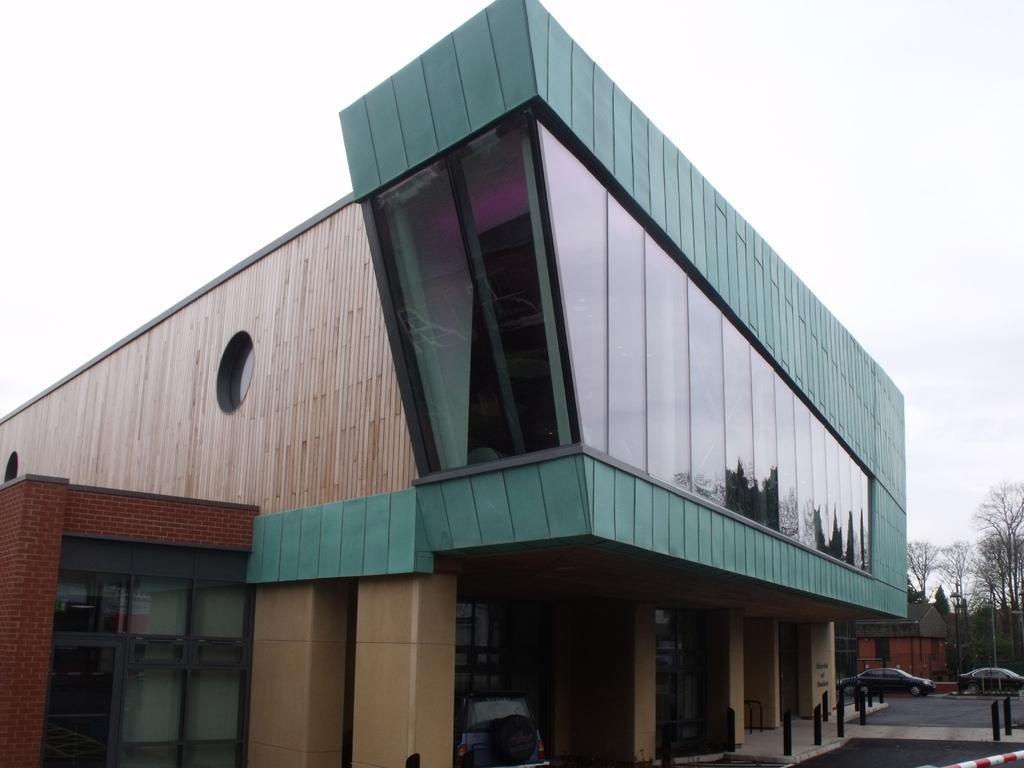Describe this image in one or two sentences. In this image we can see the building. And we can see the glass windows. And we can see the trees. And we can see some vehicles. And we can see the sky at the top. 